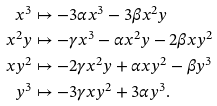Convert formula to latex. <formula><loc_0><loc_0><loc_500><loc_500>x ^ { 3 } & \mapsto - 3 \alpha x ^ { 3 } - 3 \beta x ^ { 2 } y \\ x ^ { 2 } y & \mapsto - \gamma x ^ { 3 } - \alpha x ^ { 2 } y - 2 \beta x y ^ { 2 } \\ x y ^ { 2 } & \mapsto - 2 \gamma x ^ { 2 } y + \alpha x y ^ { 2 } - \beta y ^ { 3 } \\ y ^ { 3 } & \mapsto - 3 \gamma x y ^ { 2 } + 3 \alpha y ^ { 3 } .</formula> 